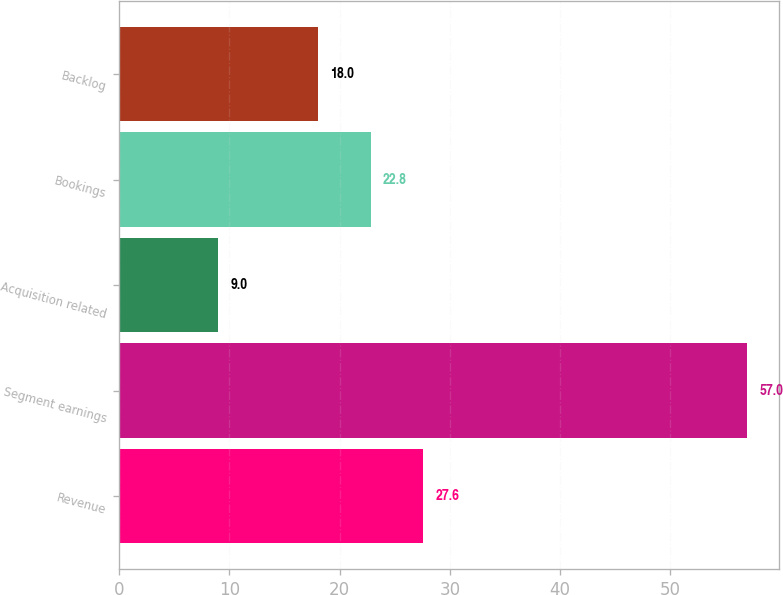Convert chart. <chart><loc_0><loc_0><loc_500><loc_500><bar_chart><fcel>Revenue<fcel>Segment earnings<fcel>Acquisition related<fcel>Bookings<fcel>Backlog<nl><fcel>27.6<fcel>57<fcel>9<fcel>22.8<fcel>18<nl></chart> 